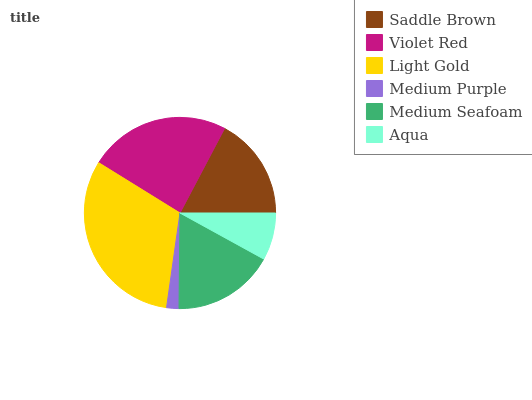Is Medium Purple the minimum?
Answer yes or no. Yes. Is Light Gold the maximum?
Answer yes or no. Yes. Is Violet Red the minimum?
Answer yes or no. No. Is Violet Red the maximum?
Answer yes or no. No. Is Violet Red greater than Saddle Brown?
Answer yes or no. Yes. Is Saddle Brown less than Violet Red?
Answer yes or no. Yes. Is Saddle Brown greater than Violet Red?
Answer yes or no. No. Is Violet Red less than Saddle Brown?
Answer yes or no. No. Is Saddle Brown the high median?
Answer yes or no. Yes. Is Medium Seafoam the low median?
Answer yes or no. Yes. Is Medium Purple the high median?
Answer yes or no. No. Is Aqua the low median?
Answer yes or no. No. 